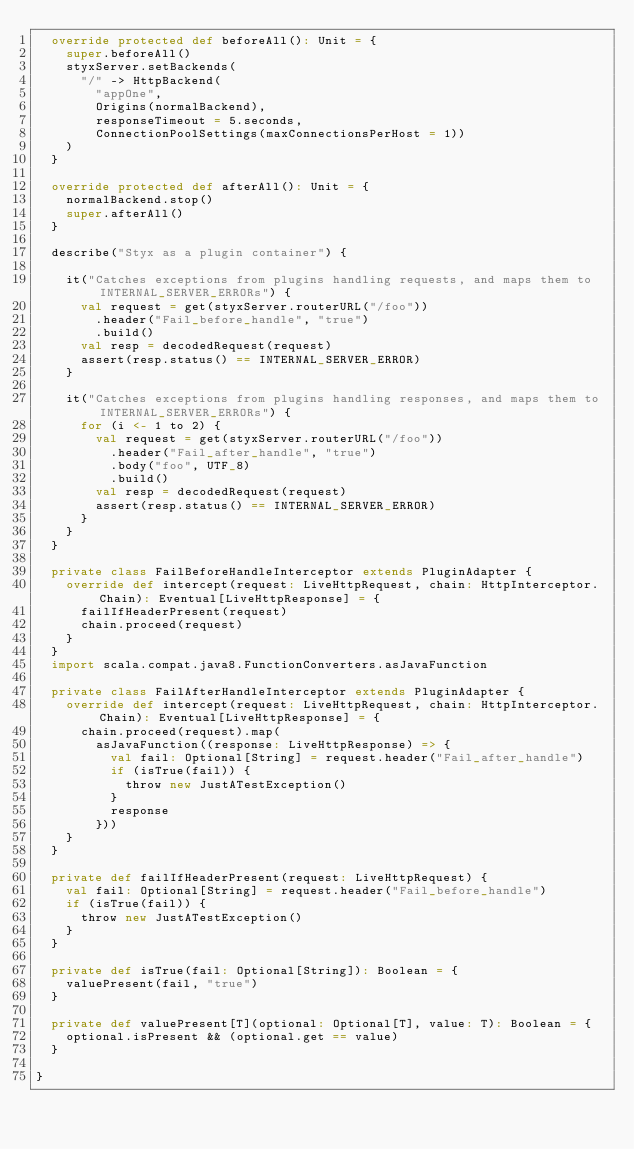<code> <loc_0><loc_0><loc_500><loc_500><_Scala_>  override protected def beforeAll(): Unit = {
    super.beforeAll()
    styxServer.setBackends(
      "/" -> HttpBackend(
        "appOne",
        Origins(normalBackend),
        responseTimeout = 5.seconds,
        ConnectionPoolSettings(maxConnectionsPerHost = 1))
    )
  }

  override protected def afterAll(): Unit = {
    normalBackend.stop()
    super.afterAll()
  }

  describe("Styx as a plugin container") {

    it("Catches exceptions from plugins handling requests, and maps them to INTERNAL_SERVER_ERRORs") {
      val request = get(styxServer.routerURL("/foo"))
        .header("Fail_before_handle", "true")
        .build()
      val resp = decodedRequest(request)
      assert(resp.status() == INTERNAL_SERVER_ERROR)
    }

    it("Catches exceptions from plugins handling responses, and maps them to INTERNAL_SERVER_ERRORs") {
      for (i <- 1 to 2) {
        val request = get(styxServer.routerURL("/foo"))
          .header("Fail_after_handle", "true")
          .body("foo", UTF_8)
          .build()
        val resp = decodedRequest(request)
        assert(resp.status() == INTERNAL_SERVER_ERROR)
      }
    }
  }

  private class FailBeforeHandleInterceptor extends PluginAdapter {
    override def intercept(request: LiveHttpRequest, chain: HttpInterceptor.Chain): Eventual[LiveHttpResponse] = {
      failIfHeaderPresent(request)
      chain.proceed(request)
    }
  }
  import scala.compat.java8.FunctionConverters.asJavaFunction

  private class FailAfterHandleInterceptor extends PluginAdapter {
    override def intercept(request: LiveHttpRequest, chain: HttpInterceptor.Chain): Eventual[LiveHttpResponse] = {
      chain.proceed(request).map(
        asJavaFunction((response: LiveHttpResponse) => {
          val fail: Optional[String] = request.header("Fail_after_handle")
          if (isTrue(fail)) {
            throw new JustATestException()
          }
          response
        }))
    }
  }

  private def failIfHeaderPresent(request: LiveHttpRequest) {
    val fail: Optional[String] = request.header("Fail_before_handle")
    if (isTrue(fail)) {
      throw new JustATestException()
    }
  }

  private def isTrue(fail: Optional[String]): Boolean = {
    valuePresent(fail, "true")
  }

  private def valuePresent[T](optional: Optional[T], value: T): Boolean = {
    optional.isPresent && (optional.get == value)
  }

}
</code> 